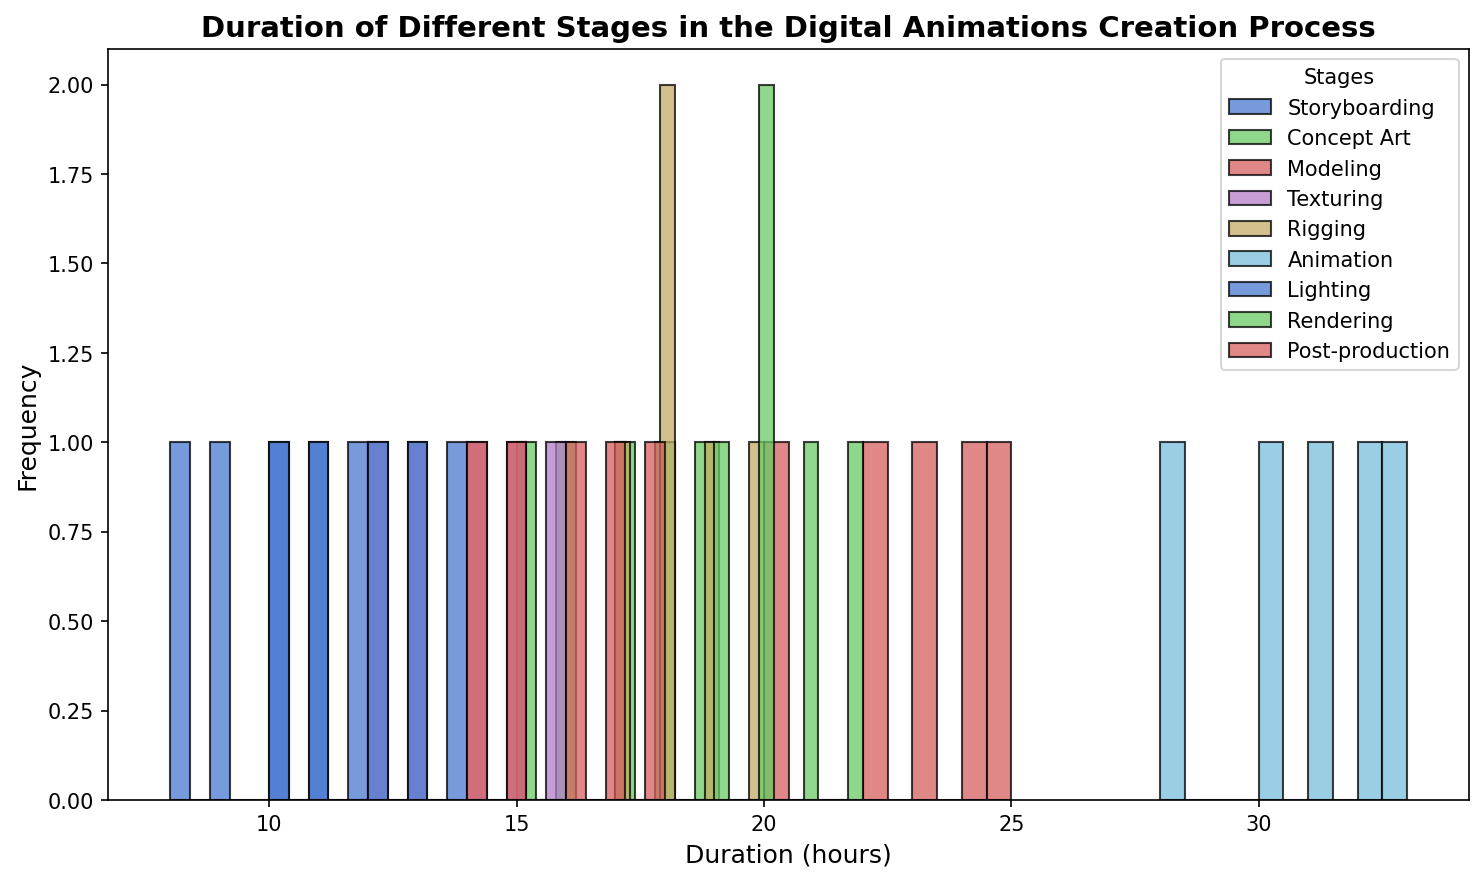Which stage has the highest average duration? To find the highest average duration, calculate the mean duration for each stage, then compare them. Storyboarding: (10+8+12+9+11)/5 = 10; Concept Art: (16+18+15+17+19)/5 = 17; Modeling: (25+22+24+23+20)/5 = 22.8; Texturing: (14+16+12+15+13)/5 = 14; Rigging: (18+19+20+17+18)/5 = 18.4; Animation: (30+32+28+31+33)/5 = 30.8; Lighting: (12+10+13+11+14)/5 = 12; Rendering: (20+22+19+21+20)/5 = 20.4; Post-production: (15+17+14+16+18)/5 = 16. Thus, Animation has the highest average duration.
Answer: Animation Which stage has the most variability in duration? Variability can be assessed using the range (max-min). The stage with the widest range indicates the most variability. Calculate it for each stage: Storyboarding: 12-8 = 4; Concept Art: 19-15 = 4; Modeling: 25-20 = 5; Texturing: 16-12 = 4; Rigging: 20-17 = 3; Animation: 33-28 = 5; Lighting: 14-10 = 4; Rendering: 22-19 = 3; Post-production: 18-14 = 4. Both Animation and Modeling have the highest range of 5.
Answer: Animation and Modeling How does the median duration compare between Concept Art and Rigging? To find the median, sort each group's durations and find the middle value. For Concept Art: [15, 16, 17, 18, 19], median = 17. For Rigging: [17, 18, 18, 19, 20], median = 18. Compare them: Concept Art's median is 1 hour less than Rigging's median.
Answer: Concept Art's median is 1 hour less than Rigging's What is the difference between the maximum duration in Animation and the maximum duration in Texturing? Identify the maximum values for each stage: Animation = 33, Texturing = 16. Difference = 33 - 16 = 17.
Answer: 17 Which stage has more instances where the duration is 20 hours or more, Modeling or Rigging? Count the number of instances where the duration is 20 or more: Modeling: [25, 22, 24, 23, 20], all 5 instances. Rigging: [18, 19, 20, 17, 18], 1 instance (20). Hence, Modeling has more instances of 20 hours or more.
Answer: Modeling What is the total duration for all instances in the Storyboarding stage? Sum up all the durations in Storyboarding: 10 + 8 + 12 + 9 + 11 = 50 hours.
Answer: 50 hours Between Texturing and Lighting, which stage has a higher median duration, and by how much? Calculate the median for both: Texturing: [12, 13, 14, 15, 16], median = 14; Lighting: [10, 11, 12, 13, 14], median = 12. Difference = 14 - 12 = 2. Texturing's median is 2 hours higher.
Answer: Texturing by 2 hours Between Concept Art and Post-production, which stage has the most frequent duration of 16 hours? Count the instances of 16 hours: Concept Art: 1 instance (16); Post-production: 1 instance (16). Both stages have the same frequency.
Answer: Same 